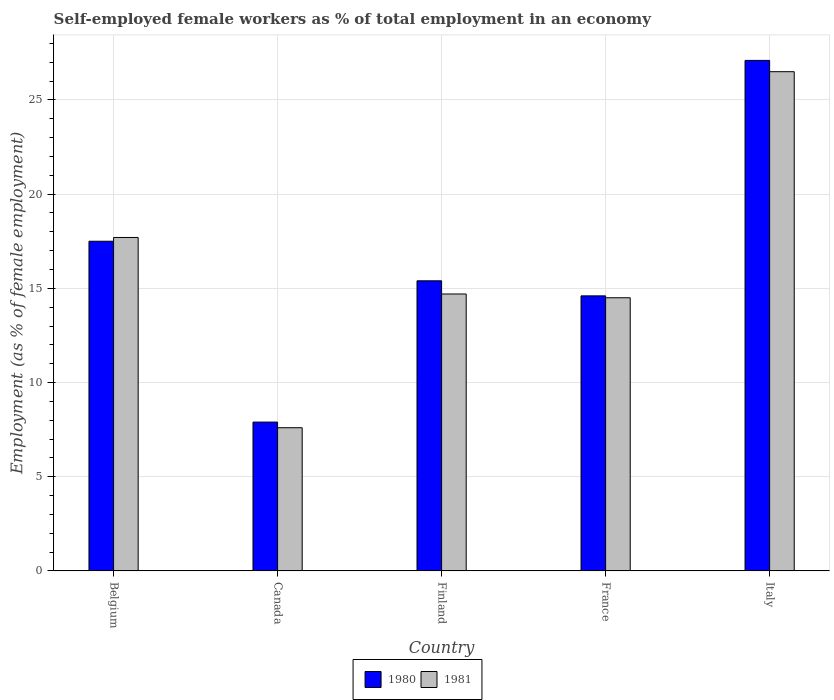How many different coloured bars are there?
Give a very brief answer. 2. How many groups of bars are there?
Provide a short and direct response. 5. Are the number of bars per tick equal to the number of legend labels?
Your answer should be very brief. Yes. Are the number of bars on each tick of the X-axis equal?
Give a very brief answer. Yes. How many bars are there on the 2nd tick from the left?
Your answer should be very brief. 2. How many bars are there on the 1st tick from the right?
Ensure brevity in your answer.  2. What is the label of the 2nd group of bars from the left?
Offer a very short reply. Canada. What is the percentage of self-employed female workers in 1980 in Finland?
Provide a succinct answer. 15.4. Across all countries, what is the minimum percentage of self-employed female workers in 1980?
Your answer should be compact. 7.9. In which country was the percentage of self-employed female workers in 1980 maximum?
Offer a very short reply. Italy. What is the total percentage of self-employed female workers in 1980 in the graph?
Make the answer very short. 82.5. What is the difference between the percentage of self-employed female workers in 1980 in Canada and that in Finland?
Keep it short and to the point. -7.5. What is the difference between the percentage of self-employed female workers in 1980 in France and the percentage of self-employed female workers in 1981 in Canada?
Offer a terse response. 7. What is the average percentage of self-employed female workers in 1981 per country?
Your answer should be compact. 16.2. What is the difference between the percentage of self-employed female workers of/in 1981 and percentage of self-employed female workers of/in 1980 in Canada?
Your response must be concise. -0.3. In how many countries, is the percentage of self-employed female workers in 1980 greater than 23 %?
Make the answer very short. 1. What is the ratio of the percentage of self-employed female workers in 1981 in Belgium to that in Finland?
Keep it short and to the point. 1.2. Is the percentage of self-employed female workers in 1980 in Finland less than that in France?
Your response must be concise. No. Is the difference between the percentage of self-employed female workers in 1981 in Canada and Italy greater than the difference between the percentage of self-employed female workers in 1980 in Canada and Italy?
Provide a short and direct response. Yes. What is the difference between the highest and the second highest percentage of self-employed female workers in 1981?
Offer a very short reply. -8.8. What is the difference between the highest and the lowest percentage of self-employed female workers in 1981?
Your response must be concise. 18.9. In how many countries, is the percentage of self-employed female workers in 1981 greater than the average percentage of self-employed female workers in 1981 taken over all countries?
Provide a short and direct response. 2. What does the 2nd bar from the left in Belgium represents?
Your response must be concise. 1981. How many bars are there?
Offer a terse response. 10. Are all the bars in the graph horizontal?
Offer a very short reply. No. What is the difference between two consecutive major ticks on the Y-axis?
Offer a terse response. 5. Does the graph contain any zero values?
Give a very brief answer. No. Where does the legend appear in the graph?
Provide a short and direct response. Bottom center. How many legend labels are there?
Your answer should be very brief. 2. What is the title of the graph?
Your answer should be very brief. Self-employed female workers as % of total employment in an economy. Does "2008" appear as one of the legend labels in the graph?
Provide a succinct answer. No. What is the label or title of the Y-axis?
Your answer should be very brief. Employment (as % of female employment). What is the Employment (as % of female employment) of 1981 in Belgium?
Your response must be concise. 17.7. What is the Employment (as % of female employment) of 1980 in Canada?
Provide a succinct answer. 7.9. What is the Employment (as % of female employment) of 1981 in Canada?
Your answer should be very brief. 7.6. What is the Employment (as % of female employment) of 1980 in Finland?
Your answer should be very brief. 15.4. What is the Employment (as % of female employment) of 1981 in Finland?
Your response must be concise. 14.7. What is the Employment (as % of female employment) in 1980 in France?
Your answer should be very brief. 14.6. What is the Employment (as % of female employment) of 1981 in France?
Your answer should be compact. 14.5. What is the Employment (as % of female employment) in 1980 in Italy?
Provide a succinct answer. 27.1. What is the Employment (as % of female employment) in 1981 in Italy?
Ensure brevity in your answer.  26.5. Across all countries, what is the maximum Employment (as % of female employment) of 1980?
Keep it short and to the point. 27.1. Across all countries, what is the minimum Employment (as % of female employment) in 1980?
Your answer should be very brief. 7.9. Across all countries, what is the minimum Employment (as % of female employment) of 1981?
Make the answer very short. 7.6. What is the total Employment (as % of female employment) of 1980 in the graph?
Ensure brevity in your answer.  82.5. What is the total Employment (as % of female employment) in 1981 in the graph?
Your answer should be compact. 81. What is the difference between the Employment (as % of female employment) of 1980 in Belgium and that in Canada?
Ensure brevity in your answer.  9.6. What is the difference between the Employment (as % of female employment) in 1980 in Belgium and that in France?
Provide a succinct answer. 2.9. What is the difference between the Employment (as % of female employment) in 1981 in Belgium and that in France?
Offer a terse response. 3.2. What is the difference between the Employment (as % of female employment) of 1980 in Canada and that in Italy?
Provide a short and direct response. -19.2. What is the difference between the Employment (as % of female employment) of 1981 in Canada and that in Italy?
Your response must be concise. -18.9. What is the difference between the Employment (as % of female employment) in 1980 in Finland and that in Italy?
Give a very brief answer. -11.7. What is the difference between the Employment (as % of female employment) in 1980 in France and that in Italy?
Offer a terse response. -12.5. What is the difference between the Employment (as % of female employment) in 1981 in France and that in Italy?
Give a very brief answer. -12. What is the difference between the Employment (as % of female employment) of 1980 in Belgium and the Employment (as % of female employment) of 1981 in Finland?
Offer a very short reply. 2.8. What is the difference between the Employment (as % of female employment) of 1980 in Belgium and the Employment (as % of female employment) of 1981 in France?
Keep it short and to the point. 3. What is the difference between the Employment (as % of female employment) in 1980 in Canada and the Employment (as % of female employment) in 1981 in Finland?
Offer a terse response. -6.8. What is the difference between the Employment (as % of female employment) in 1980 in Canada and the Employment (as % of female employment) in 1981 in France?
Make the answer very short. -6.6. What is the difference between the Employment (as % of female employment) in 1980 in Canada and the Employment (as % of female employment) in 1981 in Italy?
Offer a terse response. -18.6. What is the difference between the Employment (as % of female employment) of 1980 in Finland and the Employment (as % of female employment) of 1981 in Italy?
Ensure brevity in your answer.  -11.1. What is the difference between the Employment (as % of female employment) in 1980 in France and the Employment (as % of female employment) in 1981 in Italy?
Your response must be concise. -11.9. What is the average Employment (as % of female employment) in 1980 per country?
Offer a terse response. 16.5. What is the average Employment (as % of female employment) of 1981 per country?
Your response must be concise. 16.2. What is the difference between the Employment (as % of female employment) of 1980 and Employment (as % of female employment) of 1981 in Finland?
Your answer should be very brief. 0.7. What is the ratio of the Employment (as % of female employment) of 1980 in Belgium to that in Canada?
Offer a very short reply. 2.22. What is the ratio of the Employment (as % of female employment) of 1981 in Belgium to that in Canada?
Your answer should be very brief. 2.33. What is the ratio of the Employment (as % of female employment) in 1980 in Belgium to that in Finland?
Your answer should be very brief. 1.14. What is the ratio of the Employment (as % of female employment) in 1981 in Belgium to that in Finland?
Your answer should be very brief. 1.2. What is the ratio of the Employment (as % of female employment) in 1980 in Belgium to that in France?
Ensure brevity in your answer.  1.2. What is the ratio of the Employment (as % of female employment) of 1981 in Belgium to that in France?
Your answer should be compact. 1.22. What is the ratio of the Employment (as % of female employment) of 1980 in Belgium to that in Italy?
Your answer should be very brief. 0.65. What is the ratio of the Employment (as % of female employment) of 1981 in Belgium to that in Italy?
Provide a succinct answer. 0.67. What is the ratio of the Employment (as % of female employment) in 1980 in Canada to that in Finland?
Ensure brevity in your answer.  0.51. What is the ratio of the Employment (as % of female employment) of 1981 in Canada to that in Finland?
Your response must be concise. 0.52. What is the ratio of the Employment (as % of female employment) of 1980 in Canada to that in France?
Provide a succinct answer. 0.54. What is the ratio of the Employment (as % of female employment) in 1981 in Canada to that in France?
Offer a very short reply. 0.52. What is the ratio of the Employment (as % of female employment) of 1980 in Canada to that in Italy?
Your answer should be very brief. 0.29. What is the ratio of the Employment (as % of female employment) in 1981 in Canada to that in Italy?
Keep it short and to the point. 0.29. What is the ratio of the Employment (as % of female employment) of 1980 in Finland to that in France?
Keep it short and to the point. 1.05. What is the ratio of the Employment (as % of female employment) of 1981 in Finland to that in France?
Keep it short and to the point. 1.01. What is the ratio of the Employment (as % of female employment) of 1980 in Finland to that in Italy?
Provide a short and direct response. 0.57. What is the ratio of the Employment (as % of female employment) in 1981 in Finland to that in Italy?
Offer a very short reply. 0.55. What is the ratio of the Employment (as % of female employment) of 1980 in France to that in Italy?
Your answer should be very brief. 0.54. What is the ratio of the Employment (as % of female employment) in 1981 in France to that in Italy?
Ensure brevity in your answer.  0.55. What is the difference between the highest and the second highest Employment (as % of female employment) in 1981?
Keep it short and to the point. 8.8. What is the difference between the highest and the lowest Employment (as % of female employment) in 1980?
Give a very brief answer. 19.2. 